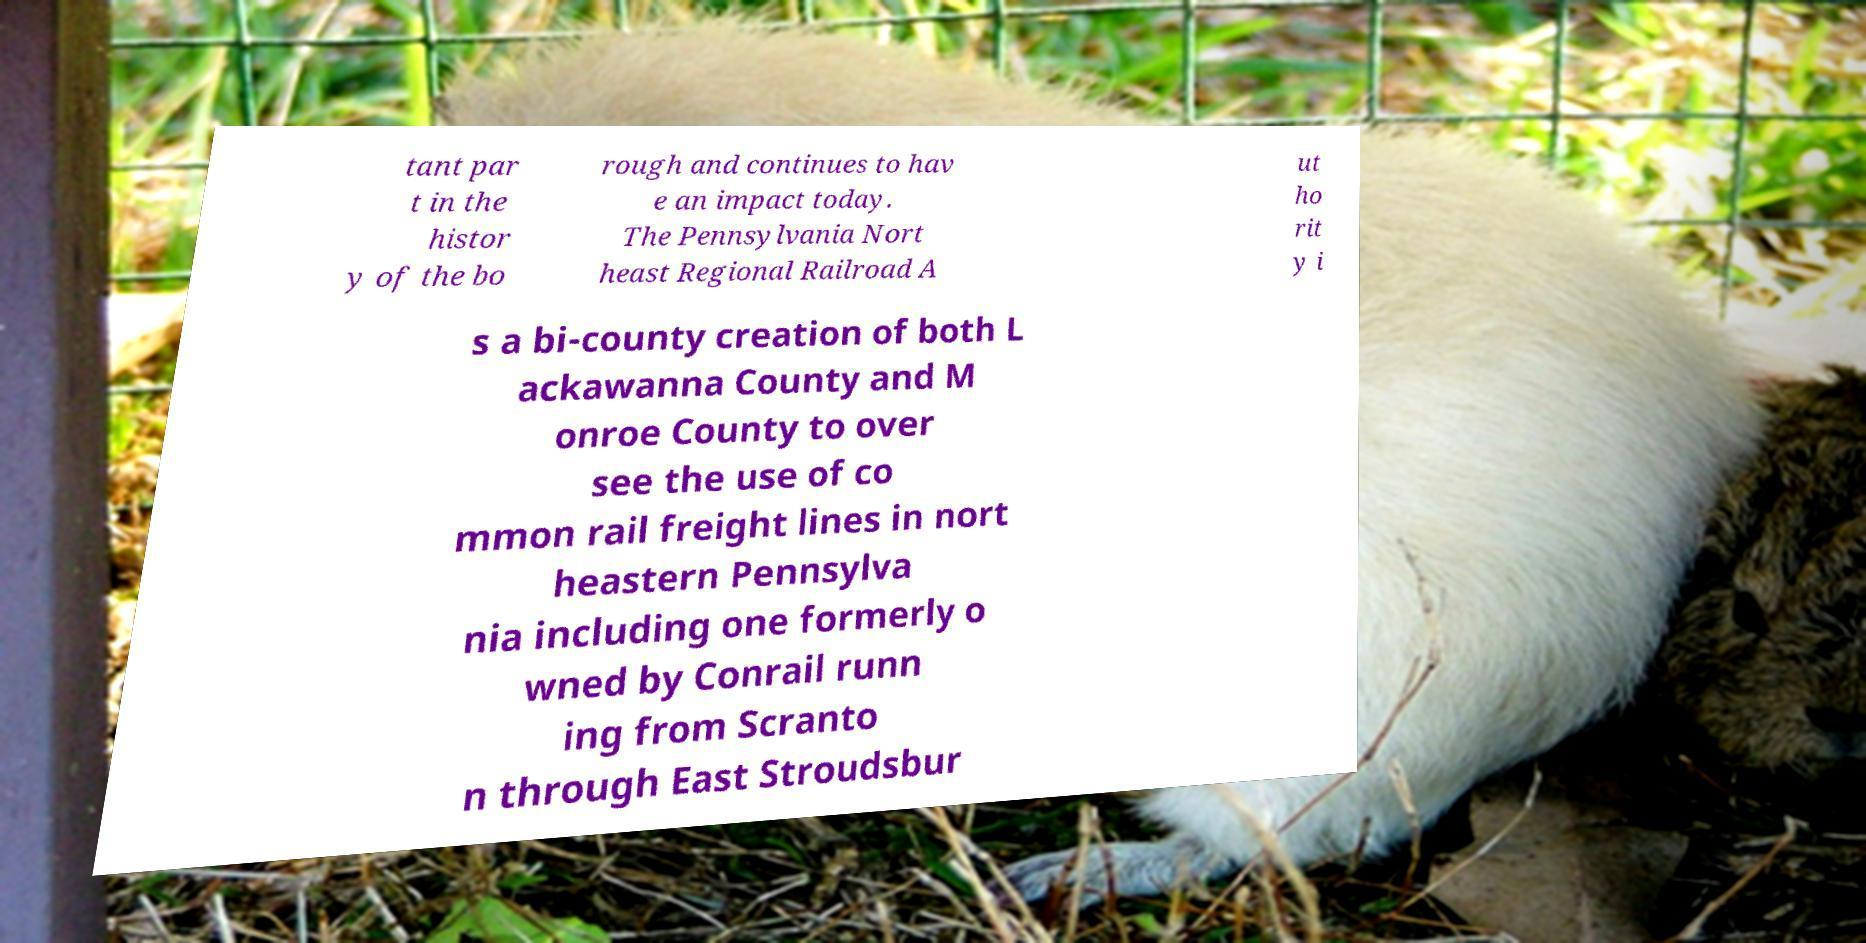Please identify and transcribe the text found in this image. tant par t in the histor y of the bo rough and continues to hav e an impact today. The Pennsylvania Nort heast Regional Railroad A ut ho rit y i s a bi-county creation of both L ackawanna County and M onroe County to over see the use of co mmon rail freight lines in nort heastern Pennsylva nia including one formerly o wned by Conrail runn ing from Scranto n through East Stroudsbur 